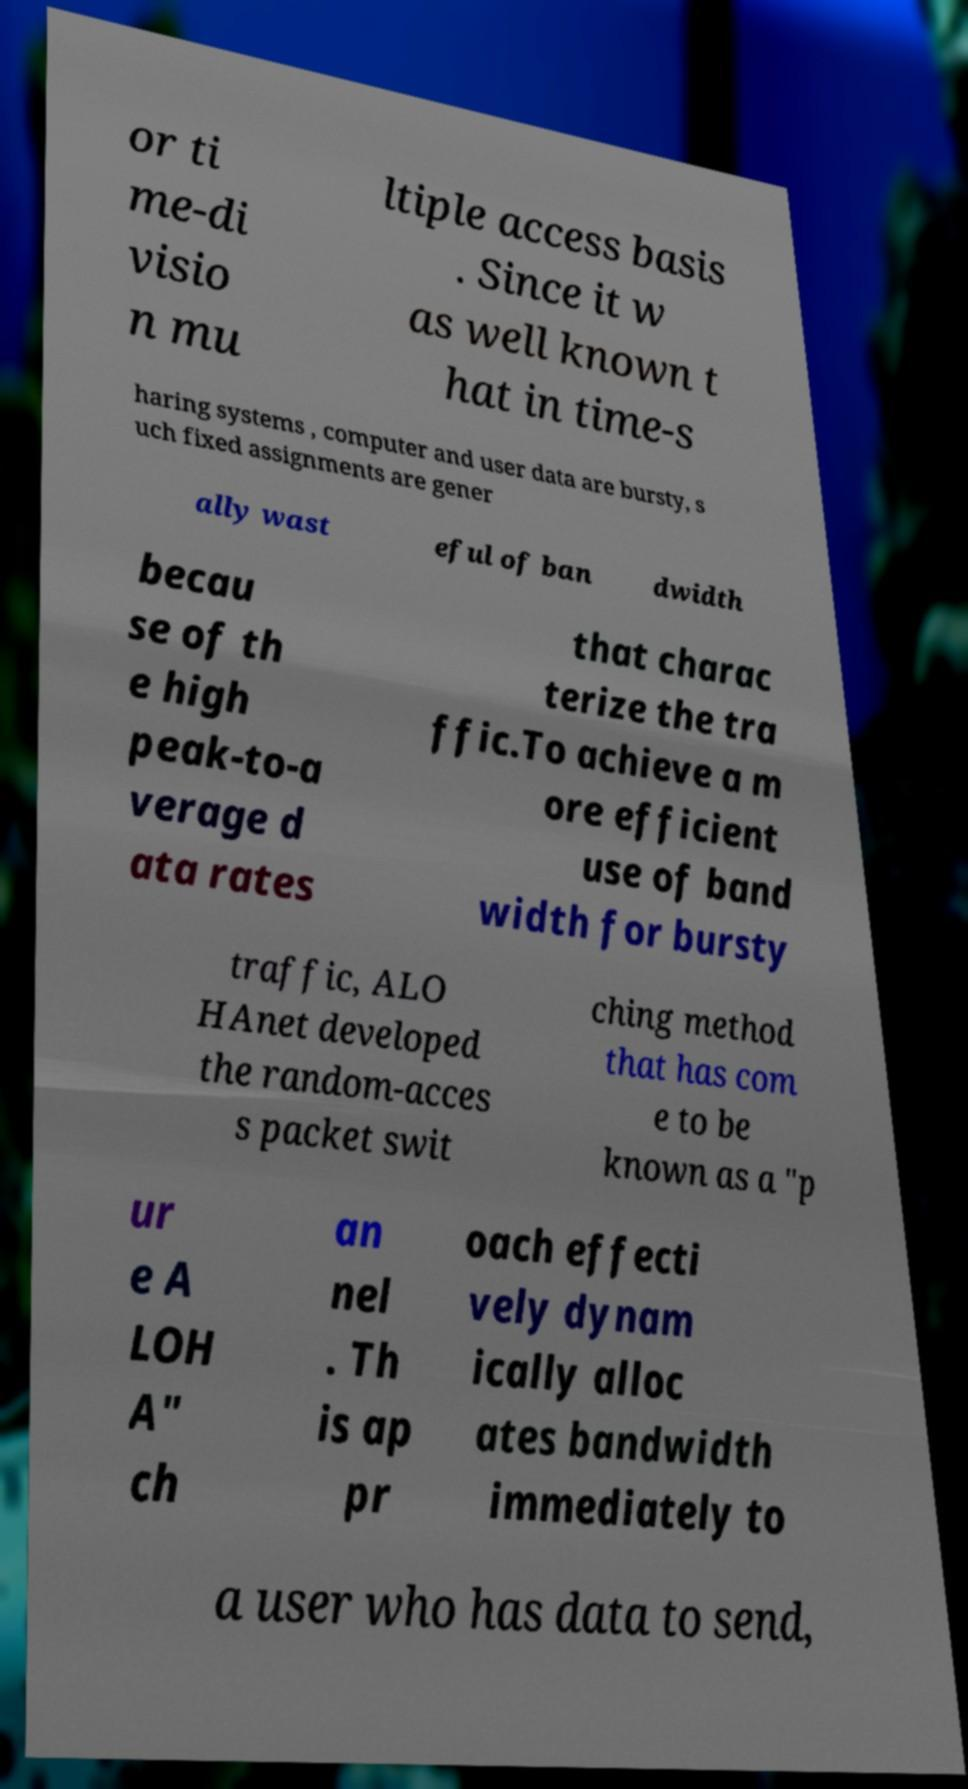For documentation purposes, I need the text within this image transcribed. Could you provide that? or ti me-di visio n mu ltiple access basis . Since it w as well known t hat in time-s haring systems , computer and user data are bursty, s uch fixed assignments are gener ally wast eful of ban dwidth becau se of th e high peak-to-a verage d ata rates that charac terize the tra ffic.To achieve a m ore efficient use of band width for bursty traffic, ALO HAnet developed the random-acces s packet swit ching method that has com e to be known as a "p ur e A LOH A" ch an nel . Th is ap pr oach effecti vely dynam ically alloc ates bandwidth immediately to a user who has data to send, 